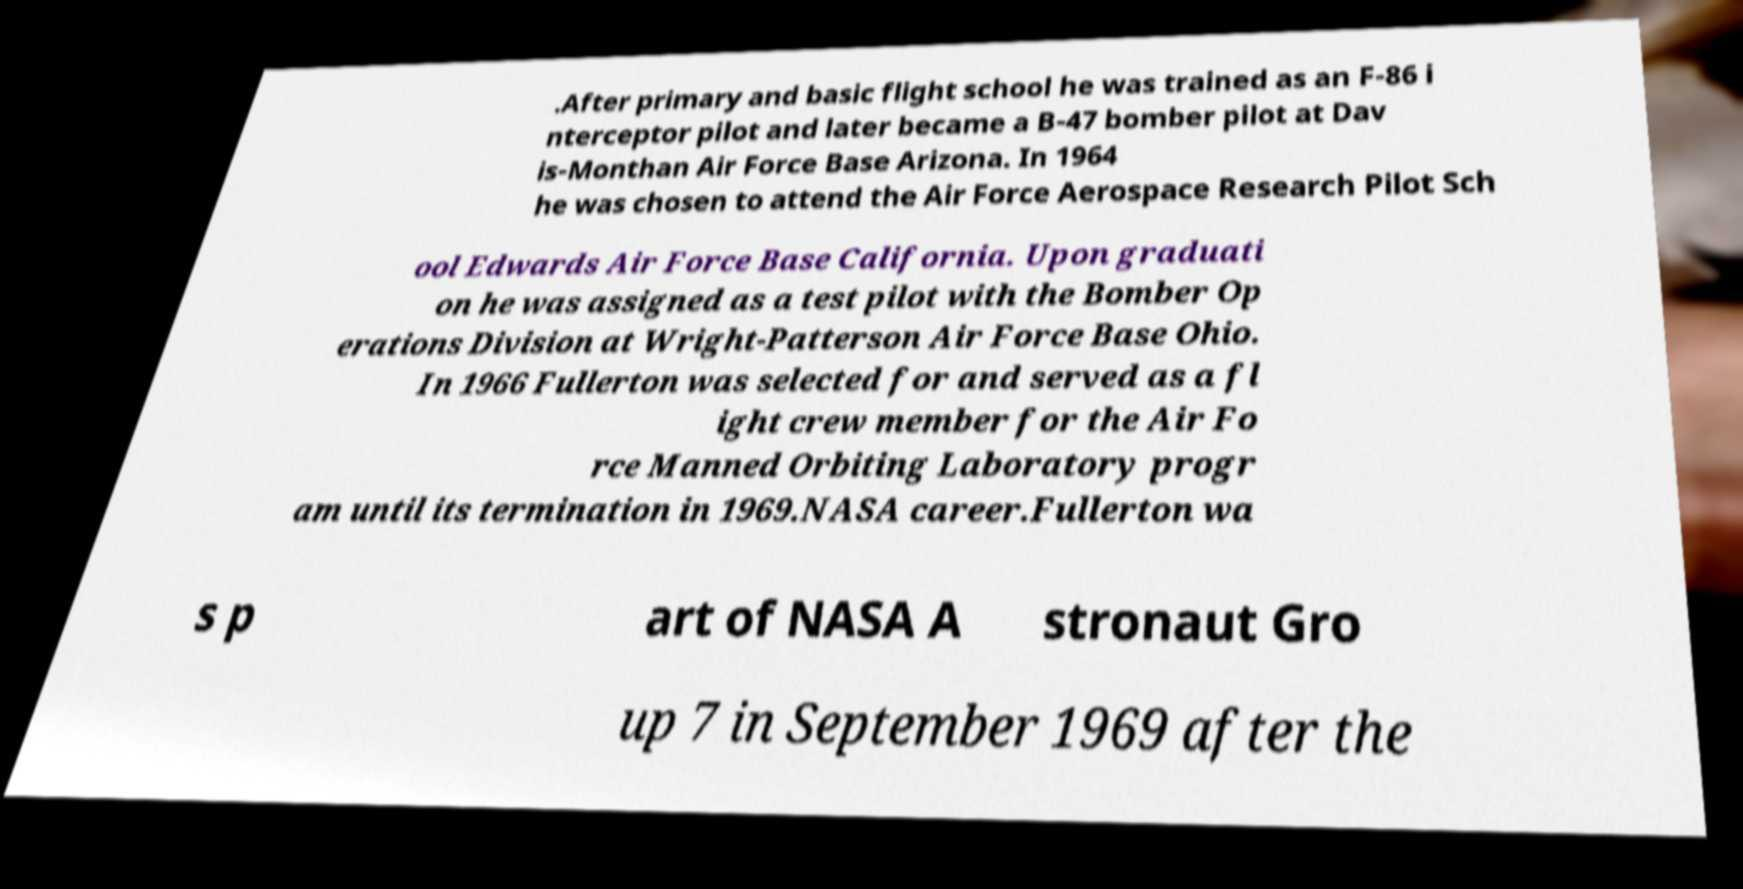Could you extract and type out the text from this image? .After primary and basic flight school he was trained as an F-86 i nterceptor pilot and later became a B-47 bomber pilot at Dav is-Monthan Air Force Base Arizona. In 1964 he was chosen to attend the Air Force Aerospace Research Pilot Sch ool Edwards Air Force Base California. Upon graduati on he was assigned as a test pilot with the Bomber Op erations Division at Wright-Patterson Air Force Base Ohio. In 1966 Fullerton was selected for and served as a fl ight crew member for the Air Fo rce Manned Orbiting Laboratory progr am until its termination in 1969.NASA career.Fullerton wa s p art of NASA A stronaut Gro up 7 in September 1969 after the 